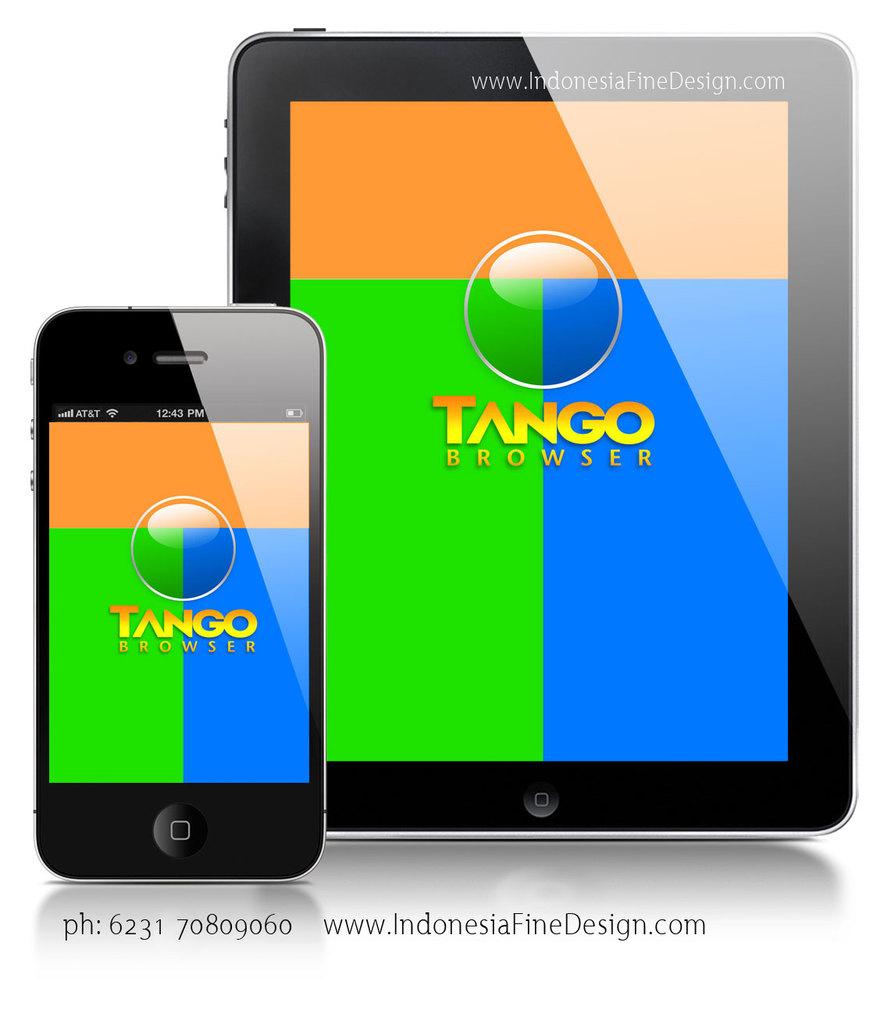What is the name of they browser being shown?
Provide a succinct answer. Tango. What is the phone number?
Your response must be concise. 6231 70809060. 